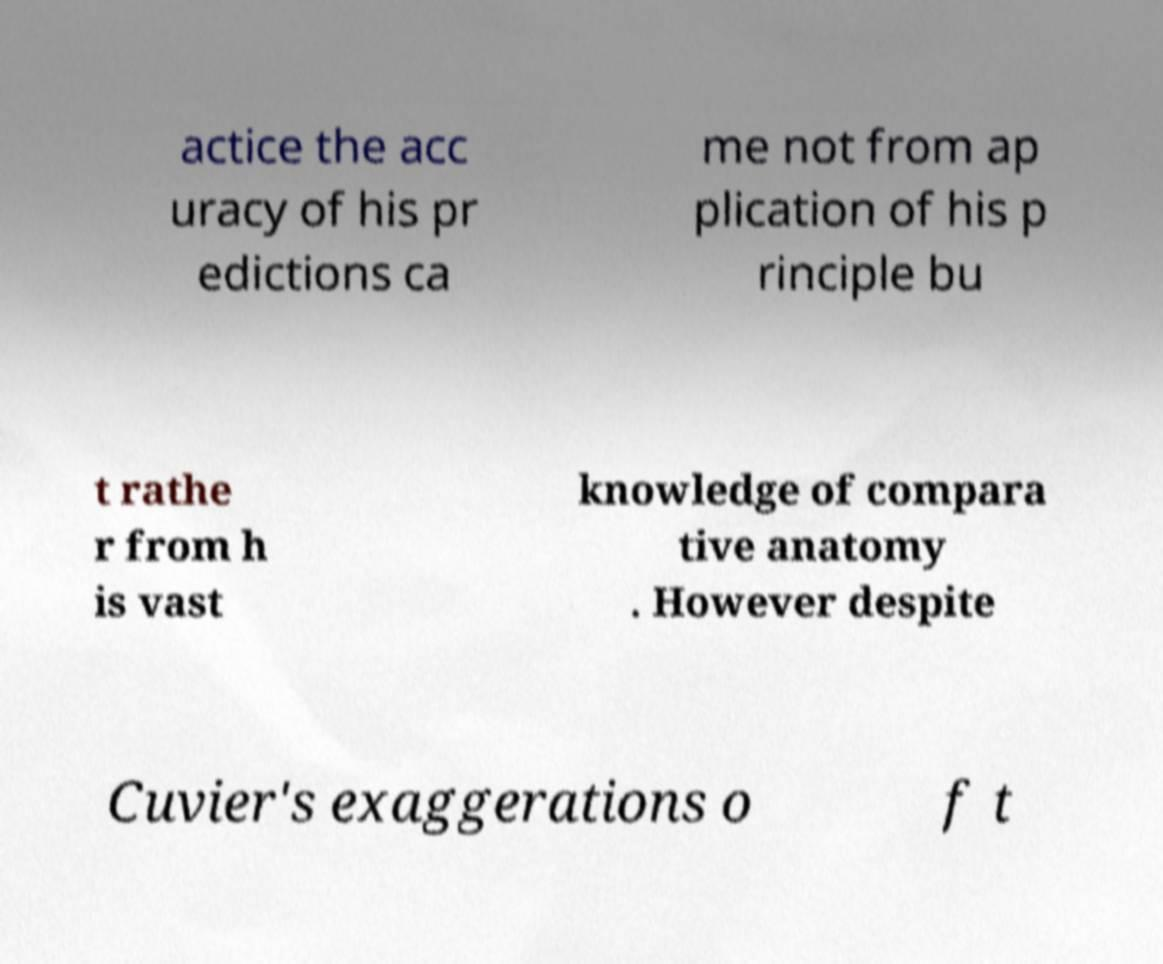What messages or text are displayed in this image? I need them in a readable, typed format. actice the acc uracy of his pr edictions ca me not from ap plication of his p rinciple bu t rathe r from h is vast knowledge of compara tive anatomy . However despite Cuvier's exaggerations o f t 